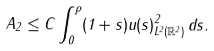Convert formula to latex. <formula><loc_0><loc_0><loc_500><loc_500>A _ { 2 } \leq C \int _ { 0 } ^ { \rho } ( 1 + s ) \| u ( s ) \| ^ { 2 } _ { L ^ { 2 } ( \mathbb { R } ^ { 2 } ) } \, d s .</formula> 